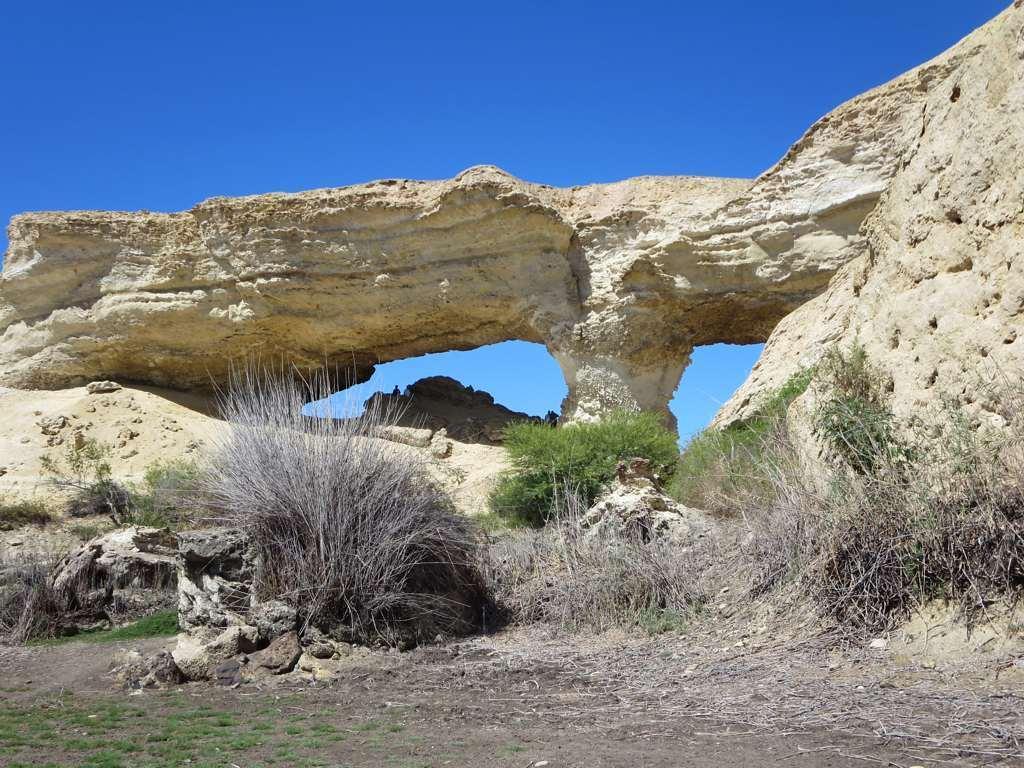Can you describe this image briefly? In the image we can see there are big stones, grass, dry grass and a blue sky. 